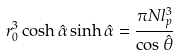Convert formula to latex. <formula><loc_0><loc_0><loc_500><loc_500>r _ { 0 } ^ { 3 } \cosh \hat { \alpha } \sinh \hat { \alpha } = \frac { \pi N l _ { p } ^ { 3 } } { \cos \hat { \theta } }</formula> 